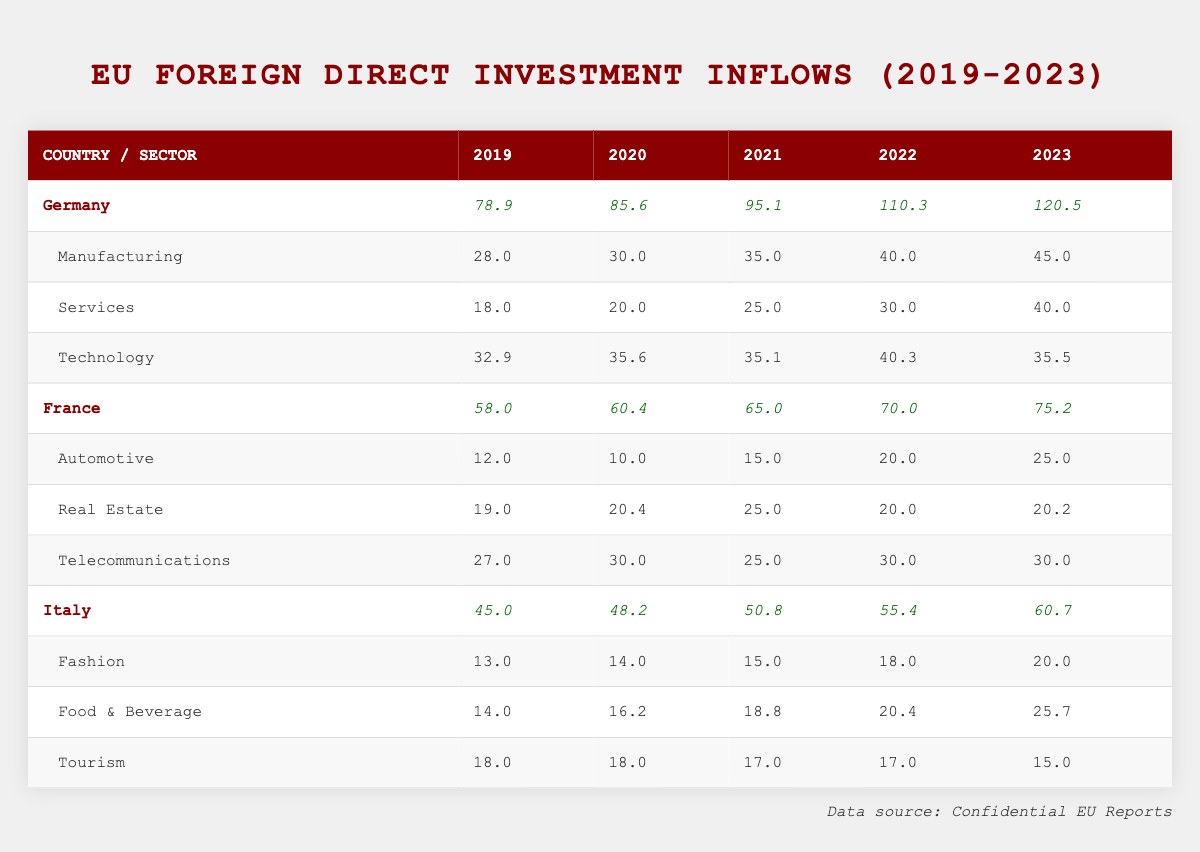What was Germany's total foreign direct investment inflow in 2023? The table shows that Germany's total inflows for 2023 is listed under the column for that year as 120.5.
Answer: 120.5 Which country had the highest total inflows in 2022? By comparing the total inflows for each country in 2022, Germany (110.3) had the highest inflows compared to France (70.0) and Italy (55.4).
Answer: Germany What is the difference in total inflows from 2020 to 2023 for France? For France, the inflows in 2020 were 60.4 and in 2023 they were 75.2. The difference is calculated as 75.2 - 60.4 = 14.8.
Answer: 14.8 Did Italy's total inflows decrease from 2022 to 2023? In 2022, Italy's total inflows were 55.4 and in 2023 they increased to 60.7, indicating a rise, not a decrease.
Answer: No What was the average total inflow for Germany over the five years from 2019 to 2023? To find the average for Germany, add the total inflows over five years: 78.9 + 85.6 + 95.1 + 110.3 + 120.5 = 490.4, and then divide by 5. The average is 490.4 / 5 = 98.08.
Answer: 98.08 Which sector in France saw an increase in inflows from 2019 to 2023? By comparing each year's inflows for each sector under France, the Automotive sector increased from 12.0 in 2019 to 25.0 in 2023. The Real Estate sector stayed relatively constant, while Telecommunications fluctuated but also stayed around similar numbers.
Answer: Automotive In what year did Italy have the lowest total foreign direct investment inflow? The total inflows for Italy over the years are 45.0 in 2019, 48.2 in 2020, 50.8 in 2021, 55.4 in 2022, and 60.7 in 2023. The lowest inflow was in 2019.
Answer: 2019 What is the combined inflow from the Technology sector in Germany for the years 2020 to 2023? To find the combined inflow from the Technology sector, add the values from 2020 to 2023: 35.6 (2020) + 35.1 (2021) + 40.3 (2022) + 35.5 (2023) = 146.5.
Answer: 146.5 